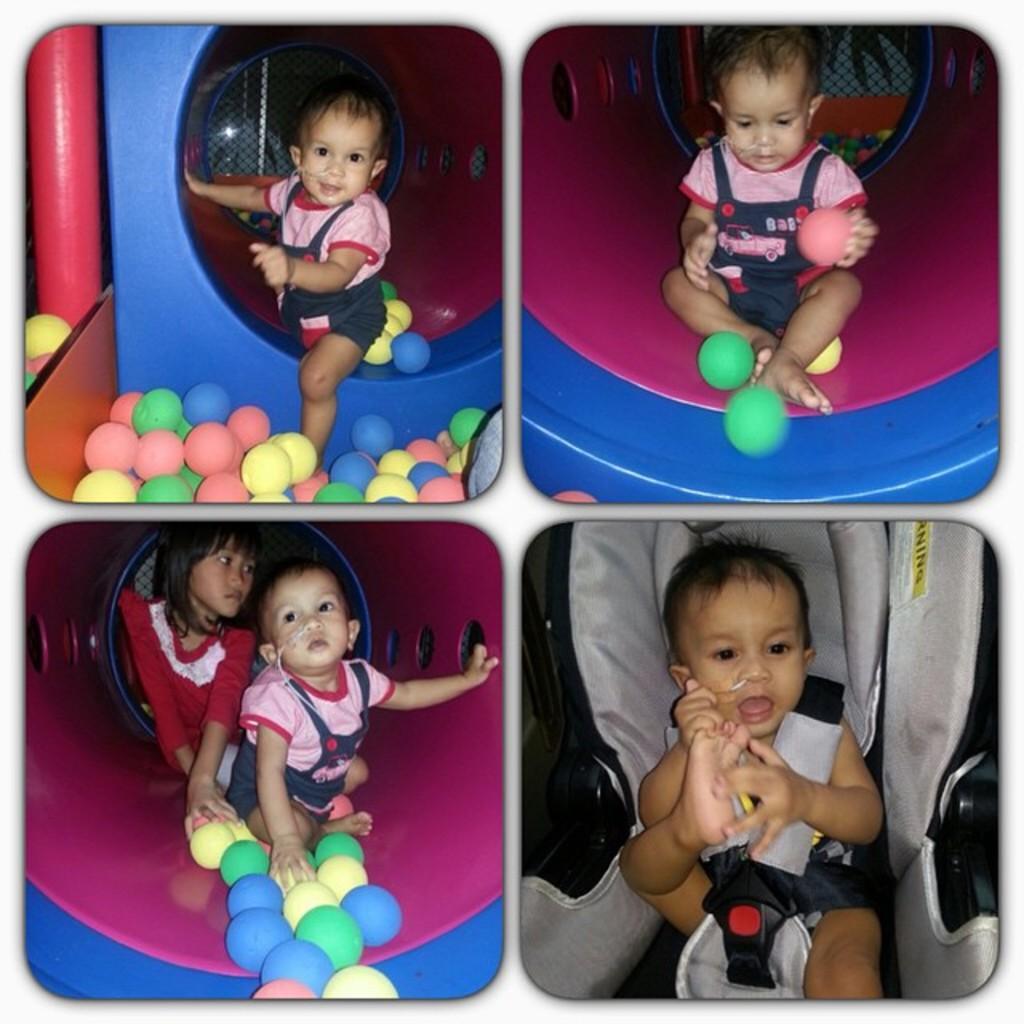In one or two sentences, can you explain what this image depicts? It is a collage picture. In the image, we can see a baby is viewing in all images. Here we can see a girl and balls. Here a baby is sitting on a seat. Left side of the image, there is a pole. Right side of the image, we can see a baby is holding a ball. 